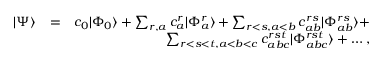Convert formula to latex. <formula><loc_0><loc_0><loc_500><loc_500>\begin{array} { r l r } { | \Psi \rangle } & { = } & { c _ { 0 } | \Phi _ { 0 } \rangle + \sum _ { r , a } c _ { a } ^ { r } | \Phi _ { a } ^ { r } \rangle + \sum _ { r < s , a < b } c _ { a b } ^ { r s } | \Phi _ { a b } ^ { r s } \rangle + } \\ & { \sum _ { r < s < t , a < b < c } c _ { a b c } ^ { r s t } | \Phi _ { a b c } ^ { r s t } \rangle + \dots , } \end{array}</formula> 